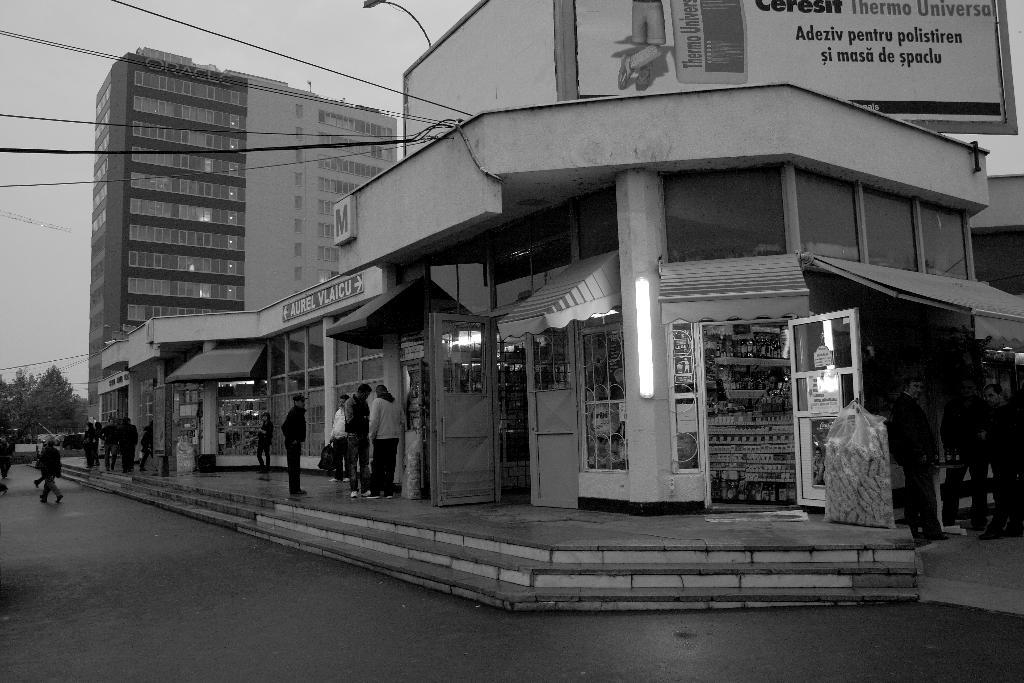What type of structures can be seen in the image? There are buildings in the image. Are there any people present in the image? Yes, there are people in the image. What type of lighting fixture is visible in the image? There is a street light in the image. Can you describe a specific feature of one of the buildings? There is a shop door in the image, which is a feature of one of the buildings. What type of cakes is the crook selling in the image? There is no crook or cakes present in the image. How does the control panel in the image affect the lighting? There is no control panel present in the image; it only features a street light. 